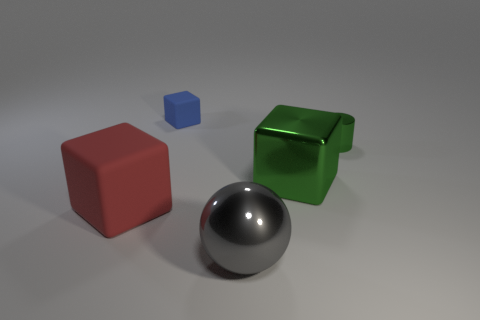Does the small metallic cylinder have the same color as the large metal block?
Ensure brevity in your answer.  Yes. There is a cube that is right of the tiny matte cube; is it the same color as the big metal thing that is in front of the big red matte object?
Your response must be concise. No. There is a green thing to the right of the big metal object that is behind the matte block that is in front of the small metallic thing; what is its material?
Offer a very short reply. Metal. Is there another block that has the same size as the green shiny cube?
Provide a succinct answer. Yes. There is a red cube that is the same size as the sphere; what material is it?
Your answer should be compact. Rubber. What is the shape of the object that is to the left of the small cube?
Your answer should be very brief. Cube. Is the green thing to the left of the tiny green cylinder made of the same material as the big block that is to the left of the tiny blue thing?
Offer a terse response. No. How many gray shiny objects are the same shape as the red rubber thing?
Your response must be concise. 0. What material is the large block that is the same color as the tiny metal cylinder?
Provide a short and direct response. Metal. How many objects are large blue matte cylinders or cubes that are behind the cylinder?
Give a very brief answer. 1. 